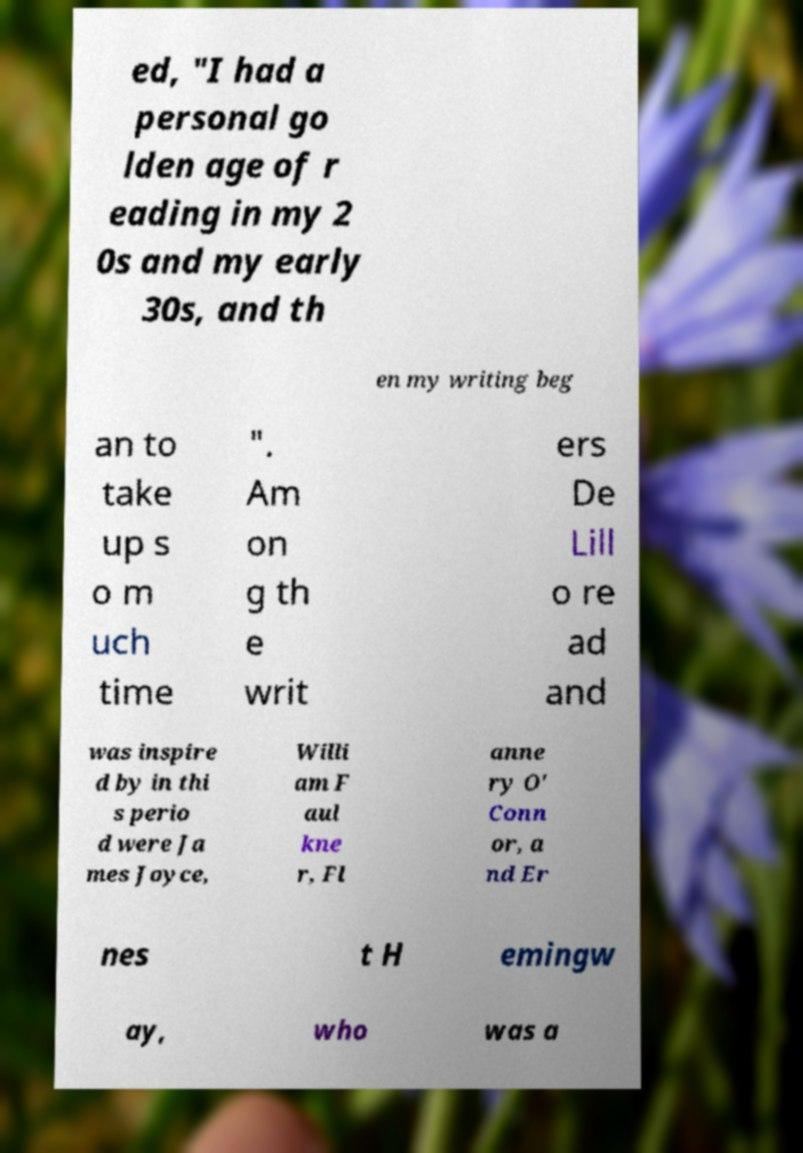Can you read and provide the text displayed in the image?This photo seems to have some interesting text. Can you extract and type it out for me? ed, "I had a personal go lden age of r eading in my 2 0s and my early 30s, and th en my writing beg an to take up s o m uch time ". Am on g th e writ ers De Lill o re ad and was inspire d by in thi s perio d were Ja mes Joyce, Willi am F aul kne r, Fl anne ry O' Conn or, a nd Er nes t H emingw ay, who was a 